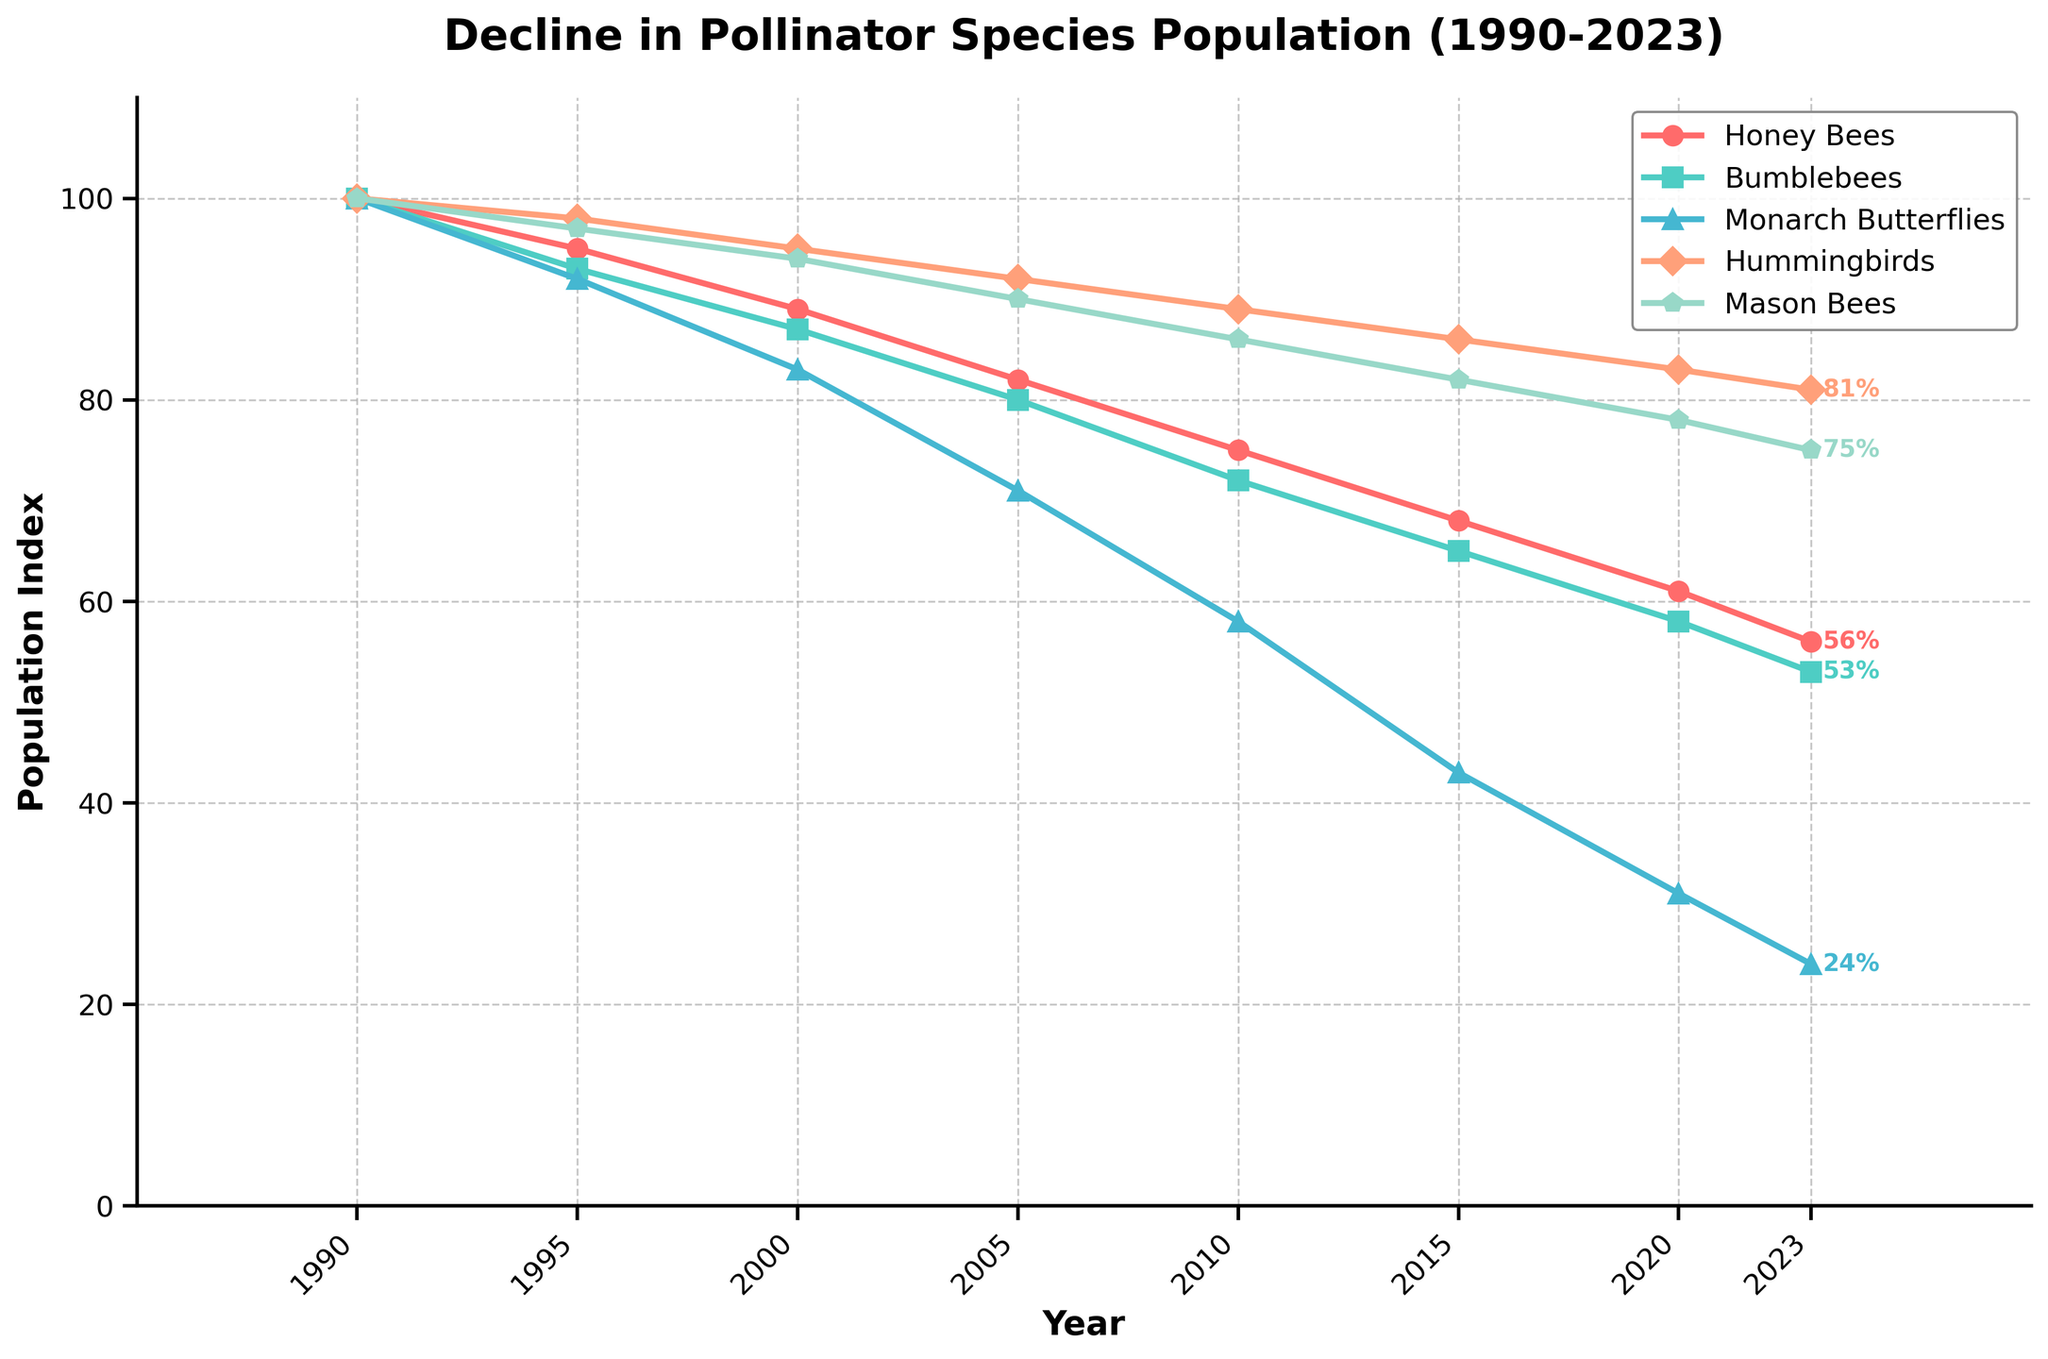What is the population index of Honey Bees in 2023? The population index of Honey Bees in 2023 is given directly in the figure. From the plot, we can see it is located at 56%.
Answer: 56% Which pollinator species shows the steepest decline from 1990 to 2023? To find the steepest decline, we look for the species with the largest decrease in the population index from 1990 to 2023. Monarch Butterflies drop from 100% in 1990 to 24% in 2023, a decline of 76%, which is the largest among all species.
Answer: Monarch Butterflies How did the population index of Hummingbirds change between 1990 and 2005? In 1990, the population index for Hummingbirds was 100%. By 2005, it had decreased to 92%. The change is calculated as 100% - 92% = 8%.
Answer: Decreased by 8% Which year saw the Mason Bees' population index drop below 80%? From the data, it becomes clear that the Mason Bees' population index fell below 80% for the first time in 2020, where it reached 78%.
Answer: 2020 Over which 5-year interval did Bumblebees experience the largest decline? To determine this, we'll compare the decline over various 5-year periods: 1990-1995 (100 to 93, decline of 7), 1995-2000 (93 to 87, decline of 6), 2000-2005 (87 to 80, decline of 7), 2005-2010 (80 to 72, decline of 8), 2010-2015 (72 to 65, decline of 7), 2015-2020 (65 to 58, decline of 7), and 2020-2023 (58 to 53, decline of 5). The largest decline occurs between 2005-2010.
Answer: 2005-2010 Which pollinator species had the smallest decline in population index over the entire period from 1990 to 2023? To determine this, we'll check each species' decline: Honey Bees (100 to 56, decline of 44), Bumblebees (100 to 53, decline of 47), Monarch Butterflies (100 to 24, decline of 76), Hummingbirds (100 to 81, decline of 19), Mason Bees (100 to 75, decline of 25). Hummingbirds show the smallest decline.
Answer: Hummingbirds By how many percentage points did the population index of Monarch Butterflies decrease between 2000 and 2015? The population index of Monarch Butterflies in 2000 was 83%, and in 2015 it was 43%. The decrease is calculated as 83% - 43% = 40%.
Answer: 40% In which period did the Honey Bees' population index exhibit a more significant drop: 1995-2000 or 2015-2020? From 1995 to 2000, Honey Bees' population index decreased from 95% to 89%, a drop of 6%. From 2015 to 2020, it decreased from 68% to 61%, a drop of 7%. Therefore, the more significant drop occurred from 2015 to 2020.
Answer: 2015-2020 Which pollinator species still has a population index above 80% by 2023? By 2023, from the figure, Hummingbirds have a population index of 81%, which is above 80%. None of the other species' population indices are above 80%.
Answer: Hummingbirds 